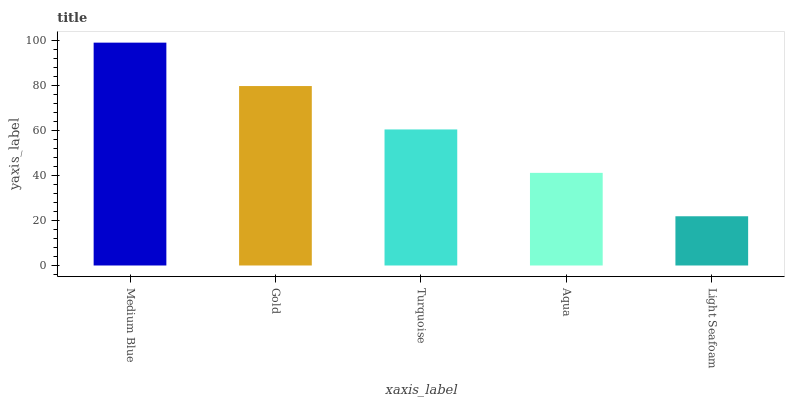Is Light Seafoam the minimum?
Answer yes or no. Yes. Is Medium Blue the maximum?
Answer yes or no. Yes. Is Gold the minimum?
Answer yes or no. No. Is Gold the maximum?
Answer yes or no. No. Is Medium Blue greater than Gold?
Answer yes or no. Yes. Is Gold less than Medium Blue?
Answer yes or no. Yes. Is Gold greater than Medium Blue?
Answer yes or no. No. Is Medium Blue less than Gold?
Answer yes or no. No. Is Turquoise the high median?
Answer yes or no. Yes. Is Turquoise the low median?
Answer yes or no. Yes. Is Gold the high median?
Answer yes or no. No. Is Medium Blue the low median?
Answer yes or no. No. 